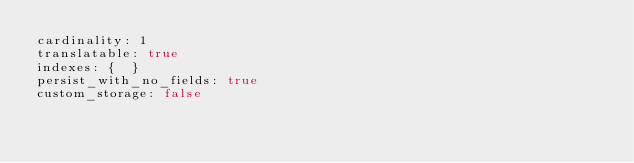<code> <loc_0><loc_0><loc_500><loc_500><_YAML_>cardinality: 1
translatable: true
indexes: {  }
persist_with_no_fields: true
custom_storage: false
</code> 